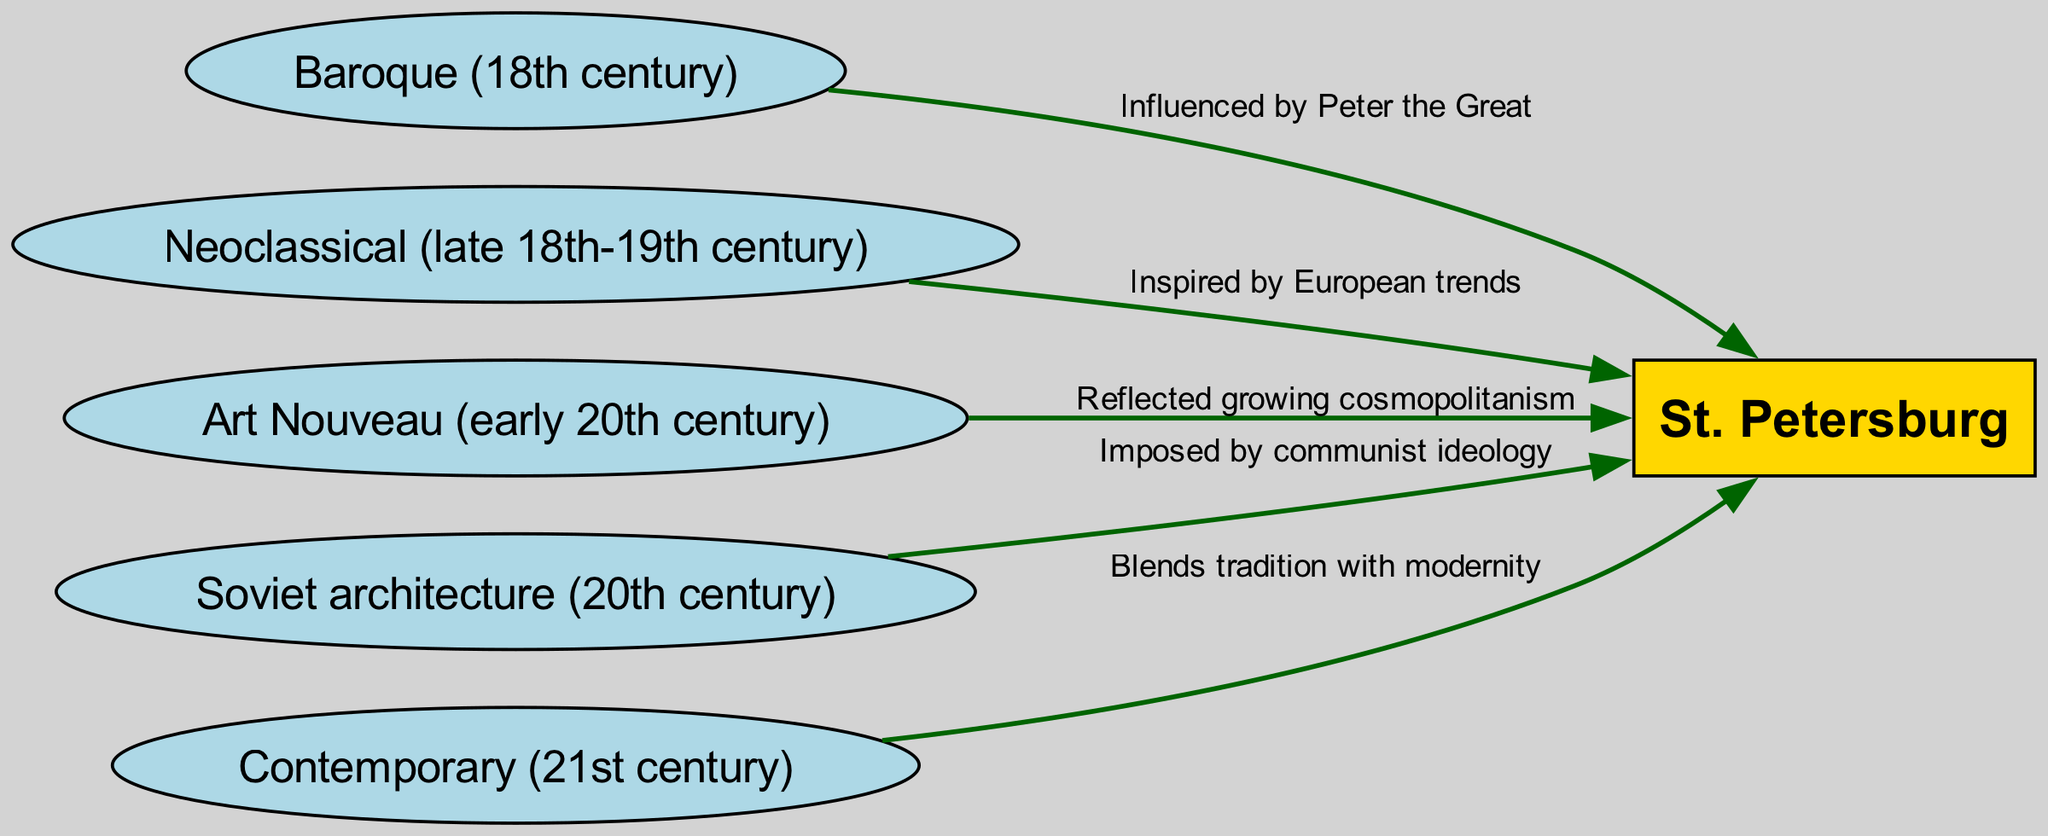What is the total number of nodes in the diagram? The diagram includes six nodes: St. Petersburg, Baroque, Neoclassical, Art Nouveau, Soviet, and Contemporary. Counting these, the total is six nodes.
Answer: 6 Which architectural style influenced St. Petersburg according to Peter the Great? The edge from Baroque to St. Petersburg indicates that Baroque architecture was influenced by Peter the Great.
Answer: Baroque How many edges are there in the diagram? There are five edges connecting various architectural styles to St. Petersburg. The edges represent the influence of each style.
Answer: 5 What does the Soviet architecture represent in its influence on St. Petersburg? The edge from Soviet to St. Petersburg states that Soviet architecture was imposed by communist ideology, indicating its significance in shaping the city.
Answer: Imposed by communist ideology Which architectural style reflects the growing cosmopolitanism in St. Petersburg? The edge from Art Nouveau to St. Petersburg indicates that Art Nouveau reflects growing cosmopolitanism in the city, highlighting its cultural significance during that time.
Answer: Art Nouveau What is the relationship between Neoclassical architecture and St. Petersburg? The diagram shows that Neoclassical architecture inspired by European trends influenced St. Petersburg, suggesting a connection to broader European cultural movements.
Answer: Inspired by European trends Which architectural style blends tradition with modernity? The edge from Contemporary to St. Petersburg states that Contemporary architecture blends tradition with modernity, showing how current architectural practices are informed by history.
Answer: Blends tradition with modernity What is the direction of influence from Baroque to St. Petersburg? The arrow directed from Baroque to St. Petersburg indicates a one-way influence, where Baroque architecture had an impact on the city’s development.
Answer: From Baroque to St. Petersburg Which cultural influence is represented by the term "Growing cosmopolitanism"? The term "Growing cosmopolitanism" is specifically associated with Art Nouveau, showing how this architectural style corresponds to the cultural evolution of St. Petersburg.
Answer: Art Nouveau 